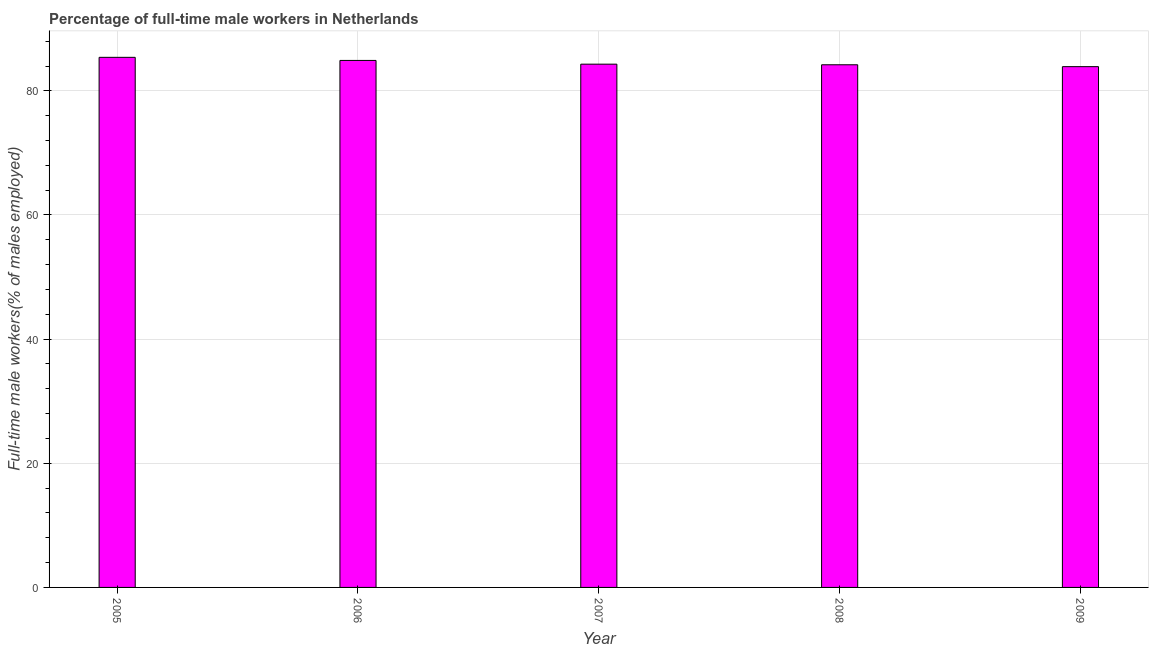Does the graph contain any zero values?
Your answer should be very brief. No. What is the title of the graph?
Keep it short and to the point. Percentage of full-time male workers in Netherlands. What is the label or title of the Y-axis?
Your response must be concise. Full-time male workers(% of males employed). What is the percentage of full-time male workers in 2007?
Keep it short and to the point. 84.3. Across all years, what is the maximum percentage of full-time male workers?
Provide a succinct answer. 85.4. Across all years, what is the minimum percentage of full-time male workers?
Make the answer very short. 83.9. In which year was the percentage of full-time male workers maximum?
Ensure brevity in your answer.  2005. What is the sum of the percentage of full-time male workers?
Your response must be concise. 422.7. What is the difference between the percentage of full-time male workers in 2006 and 2009?
Offer a terse response. 1. What is the average percentage of full-time male workers per year?
Ensure brevity in your answer.  84.54. What is the median percentage of full-time male workers?
Your answer should be very brief. 84.3. Do a majority of the years between 2008 and 2005 (inclusive) have percentage of full-time male workers greater than 72 %?
Offer a very short reply. Yes. What is the ratio of the percentage of full-time male workers in 2007 to that in 2009?
Ensure brevity in your answer.  1. Is the percentage of full-time male workers in 2006 less than that in 2007?
Your answer should be compact. No. Is the difference between the percentage of full-time male workers in 2005 and 2006 greater than the difference between any two years?
Provide a succinct answer. No. What is the difference between the highest and the second highest percentage of full-time male workers?
Give a very brief answer. 0.5. What is the difference between the highest and the lowest percentage of full-time male workers?
Give a very brief answer. 1.5. Are all the bars in the graph horizontal?
Offer a terse response. No. How many years are there in the graph?
Provide a short and direct response. 5. What is the difference between two consecutive major ticks on the Y-axis?
Your answer should be compact. 20. Are the values on the major ticks of Y-axis written in scientific E-notation?
Offer a terse response. No. What is the Full-time male workers(% of males employed) in 2005?
Offer a terse response. 85.4. What is the Full-time male workers(% of males employed) of 2006?
Your answer should be very brief. 84.9. What is the Full-time male workers(% of males employed) in 2007?
Ensure brevity in your answer.  84.3. What is the Full-time male workers(% of males employed) of 2008?
Make the answer very short. 84.2. What is the Full-time male workers(% of males employed) of 2009?
Provide a succinct answer. 83.9. What is the difference between the Full-time male workers(% of males employed) in 2005 and 2008?
Keep it short and to the point. 1.2. What is the difference between the Full-time male workers(% of males employed) in 2005 and 2009?
Your answer should be very brief. 1.5. What is the difference between the Full-time male workers(% of males employed) in 2006 and 2009?
Your answer should be very brief. 1. What is the difference between the Full-time male workers(% of males employed) in 2007 and 2008?
Offer a terse response. 0.1. What is the difference between the Full-time male workers(% of males employed) in 2007 and 2009?
Keep it short and to the point. 0.4. What is the ratio of the Full-time male workers(% of males employed) in 2005 to that in 2006?
Offer a very short reply. 1.01. What is the ratio of the Full-time male workers(% of males employed) in 2005 to that in 2008?
Keep it short and to the point. 1.01. What is the ratio of the Full-time male workers(% of males employed) in 2006 to that in 2008?
Offer a very short reply. 1.01. What is the ratio of the Full-time male workers(% of males employed) in 2006 to that in 2009?
Ensure brevity in your answer.  1.01. What is the ratio of the Full-time male workers(% of males employed) in 2007 to that in 2008?
Give a very brief answer. 1. What is the ratio of the Full-time male workers(% of males employed) in 2008 to that in 2009?
Ensure brevity in your answer.  1. 